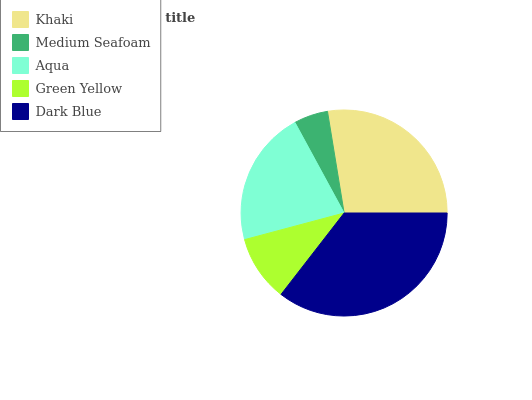Is Medium Seafoam the minimum?
Answer yes or no. Yes. Is Dark Blue the maximum?
Answer yes or no. Yes. Is Aqua the minimum?
Answer yes or no. No. Is Aqua the maximum?
Answer yes or no. No. Is Aqua greater than Medium Seafoam?
Answer yes or no. Yes. Is Medium Seafoam less than Aqua?
Answer yes or no. Yes. Is Medium Seafoam greater than Aqua?
Answer yes or no. No. Is Aqua less than Medium Seafoam?
Answer yes or no. No. Is Aqua the high median?
Answer yes or no. Yes. Is Aqua the low median?
Answer yes or no. Yes. Is Khaki the high median?
Answer yes or no. No. Is Green Yellow the low median?
Answer yes or no. No. 